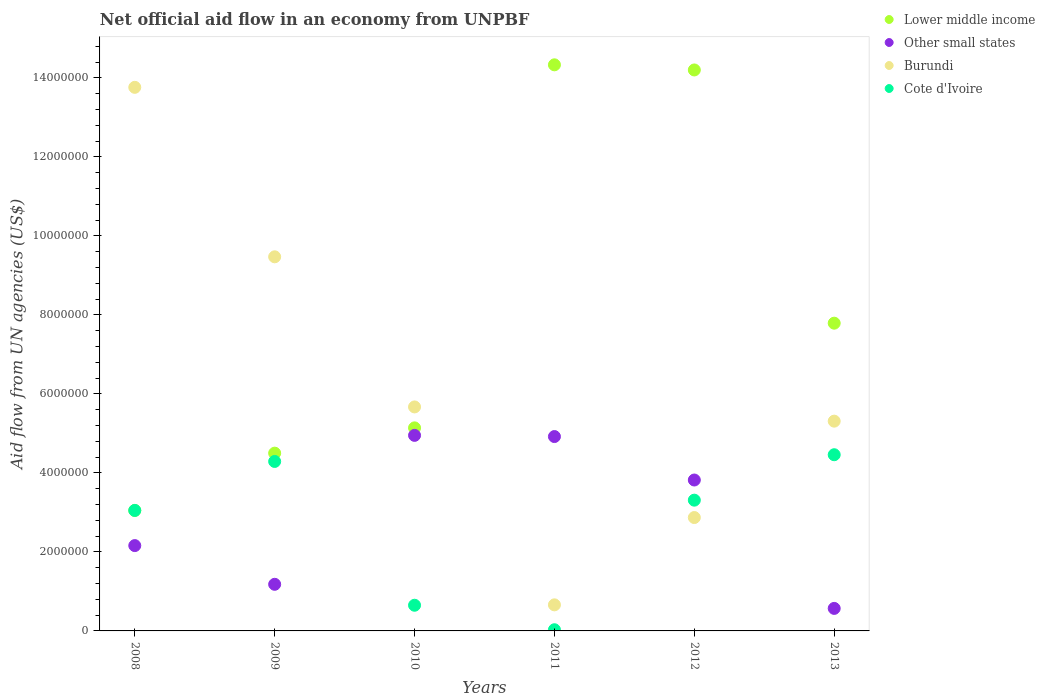What is the net official aid flow in Lower middle income in 2008?
Offer a terse response. 3.05e+06. Across all years, what is the maximum net official aid flow in Burundi?
Your answer should be very brief. 1.38e+07. Across all years, what is the minimum net official aid flow in Other small states?
Give a very brief answer. 5.70e+05. In which year was the net official aid flow in Cote d'Ivoire maximum?
Give a very brief answer. 2013. In which year was the net official aid flow in Cote d'Ivoire minimum?
Offer a terse response. 2011. What is the total net official aid flow in Lower middle income in the graph?
Provide a short and direct response. 4.90e+07. What is the difference between the net official aid flow in Burundi in 2009 and that in 2011?
Your answer should be compact. 8.81e+06. What is the difference between the net official aid flow in Cote d'Ivoire in 2008 and the net official aid flow in Burundi in 2012?
Give a very brief answer. 1.80e+05. What is the average net official aid flow in Other small states per year?
Ensure brevity in your answer.  2.93e+06. In the year 2010, what is the difference between the net official aid flow in Lower middle income and net official aid flow in Cote d'Ivoire?
Make the answer very short. 4.49e+06. What is the ratio of the net official aid flow in Burundi in 2009 to that in 2011?
Your response must be concise. 14.35. Is the net official aid flow in Cote d'Ivoire in 2009 less than that in 2012?
Make the answer very short. No. What is the difference between the highest and the second highest net official aid flow in Other small states?
Provide a short and direct response. 3.00e+04. What is the difference between the highest and the lowest net official aid flow in Burundi?
Make the answer very short. 1.31e+07. In how many years, is the net official aid flow in Other small states greater than the average net official aid flow in Other small states taken over all years?
Keep it short and to the point. 3. Is the sum of the net official aid flow in Burundi in 2008 and 2012 greater than the maximum net official aid flow in Other small states across all years?
Offer a terse response. Yes. Does the net official aid flow in Other small states monotonically increase over the years?
Your answer should be compact. No. How many dotlines are there?
Your answer should be very brief. 4. How many years are there in the graph?
Provide a succinct answer. 6. Does the graph contain any zero values?
Keep it short and to the point. No. Does the graph contain grids?
Your answer should be very brief. No. Where does the legend appear in the graph?
Keep it short and to the point. Top right. How are the legend labels stacked?
Your answer should be very brief. Vertical. What is the title of the graph?
Offer a very short reply. Net official aid flow in an economy from UNPBF. Does "Comoros" appear as one of the legend labels in the graph?
Provide a short and direct response. No. What is the label or title of the X-axis?
Keep it short and to the point. Years. What is the label or title of the Y-axis?
Your response must be concise. Aid flow from UN agencies (US$). What is the Aid flow from UN agencies (US$) in Lower middle income in 2008?
Provide a succinct answer. 3.05e+06. What is the Aid flow from UN agencies (US$) of Other small states in 2008?
Your response must be concise. 2.16e+06. What is the Aid flow from UN agencies (US$) in Burundi in 2008?
Provide a short and direct response. 1.38e+07. What is the Aid flow from UN agencies (US$) in Cote d'Ivoire in 2008?
Provide a short and direct response. 3.05e+06. What is the Aid flow from UN agencies (US$) in Lower middle income in 2009?
Your answer should be very brief. 4.50e+06. What is the Aid flow from UN agencies (US$) in Other small states in 2009?
Your answer should be very brief. 1.18e+06. What is the Aid flow from UN agencies (US$) of Burundi in 2009?
Your answer should be very brief. 9.47e+06. What is the Aid flow from UN agencies (US$) in Cote d'Ivoire in 2009?
Provide a succinct answer. 4.29e+06. What is the Aid flow from UN agencies (US$) in Lower middle income in 2010?
Keep it short and to the point. 5.14e+06. What is the Aid flow from UN agencies (US$) in Other small states in 2010?
Your response must be concise. 4.95e+06. What is the Aid flow from UN agencies (US$) of Burundi in 2010?
Offer a very short reply. 5.67e+06. What is the Aid flow from UN agencies (US$) in Cote d'Ivoire in 2010?
Provide a short and direct response. 6.50e+05. What is the Aid flow from UN agencies (US$) in Lower middle income in 2011?
Your response must be concise. 1.43e+07. What is the Aid flow from UN agencies (US$) of Other small states in 2011?
Your answer should be compact. 4.92e+06. What is the Aid flow from UN agencies (US$) of Cote d'Ivoire in 2011?
Provide a succinct answer. 3.00e+04. What is the Aid flow from UN agencies (US$) in Lower middle income in 2012?
Offer a very short reply. 1.42e+07. What is the Aid flow from UN agencies (US$) of Other small states in 2012?
Your response must be concise. 3.82e+06. What is the Aid flow from UN agencies (US$) of Burundi in 2012?
Your response must be concise. 2.87e+06. What is the Aid flow from UN agencies (US$) of Cote d'Ivoire in 2012?
Offer a terse response. 3.31e+06. What is the Aid flow from UN agencies (US$) in Lower middle income in 2013?
Offer a very short reply. 7.79e+06. What is the Aid flow from UN agencies (US$) in Other small states in 2013?
Provide a short and direct response. 5.70e+05. What is the Aid flow from UN agencies (US$) in Burundi in 2013?
Offer a terse response. 5.31e+06. What is the Aid flow from UN agencies (US$) in Cote d'Ivoire in 2013?
Your response must be concise. 4.46e+06. Across all years, what is the maximum Aid flow from UN agencies (US$) of Lower middle income?
Your answer should be compact. 1.43e+07. Across all years, what is the maximum Aid flow from UN agencies (US$) in Other small states?
Offer a terse response. 4.95e+06. Across all years, what is the maximum Aid flow from UN agencies (US$) in Burundi?
Offer a terse response. 1.38e+07. Across all years, what is the maximum Aid flow from UN agencies (US$) of Cote d'Ivoire?
Give a very brief answer. 4.46e+06. Across all years, what is the minimum Aid flow from UN agencies (US$) in Lower middle income?
Offer a terse response. 3.05e+06. Across all years, what is the minimum Aid flow from UN agencies (US$) of Other small states?
Give a very brief answer. 5.70e+05. Across all years, what is the minimum Aid flow from UN agencies (US$) of Cote d'Ivoire?
Offer a terse response. 3.00e+04. What is the total Aid flow from UN agencies (US$) in Lower middle income in the graph?
Provide a succinct answer. 4.90e+07. What is the total Aid flow from UN agencies (US$) in Other small states in the graph?
Offer a terse response. 1.76e+07. What is the total Aid flow from UN agencies (US$) in Burundi in the graph?
Provide a succinct answer. 3.77e+07. What is the total Aid flow from UN agencies (US$) of Cote d'Ivoire in the graph?
Ensure brevity in your answer.  1.58e+07. What is the difference between the Aid flow from UN agencies (US$) in Lower middle income in 2008 and that in 2009?
Offer a terse response. -1.45e+06. What is the difference between the Aid flow from UN agencies (US$) in Other small states in 2008 and that in 2009?
Give a very brief answer. 9.80e+05. What is the difference between the Aid flow from UN agencies (US$) of Burundi in 2008 and that in 2009?
Provide a succinct answer. 4.29e+06. What is the difference between the Aid flow from UN agencies (US$) in Cote d'Ivoire in 2008 and that in 2009?
Give a very brief answer. -1.24e+06. What is the difference between the Aid flow from UN agencies (US$) of Lower middle income in 2008 and that in 2010?
Make the answer very short. -2.09e+06. What is the difference between the Aid flow from UN agencies (US$) in Other small states in 2008 and that in 2010?
Ensure brevity in your answer.  -2.79e+06. What is the difference between the Aid flow from UN agencies (US$) of Burundi in 2008 and that in 2010?
Provide a succinct answer. 8.09e+06. What is the difference between the Aid flow from UN agencies (US$) in Cote d'Ivoire in 2008 and that in 2010?
Offer a terse response. 2.40e+06. What is the difference between the Aid flow from UN agencies (US$) in Lower middle income in 2008 and that in 2011?
Your answer should be very brief. -1.13e+07. What is the difference between the Aid flow from UN agencies (US$) of Other small states in 2008 and that in 2011?
Keep it short and to the point. -2.76e+06. What is the difference between the Aid flow from UN agencies (US$) in Burundi in 2008 and that in 2011?
Your answer should be compact. 1.31e+07. What is the difference between the Aid flow from UN agencies (US$) in Cote d'Ivoire in 2008 and that in 2011?
Keep it short and to the point. 3.02e+06. What is the difference between the Aid flow from UN agencies (US$) in Lower middle income in 2008 and that in 2012?
Your response must be concise. -1.12e+07. What is the difference between the Aid flow from UN agencies (US$) of Other small states in 2008 and that in 2012?
Give a very brief answer. -1.66e+06. What is the difference between the Aid flow from UN agencies (US$) of Burundi in 2008 and that in 2012?
Ensure brevity in your answer.  1.09e+07. What is the difference between the Aid flow from UN agencies (US$) of Cote d'Ivoire in 2008 and that in 2012?
Keep it short and to the point. -2.60e+05. What is the difference between the Aid flow from UN agencies (US$) in Lower middle income in 2008 and that in 2013?
Keep it short and to the point. -4.74e+06. What is the difference between the Aid flow from UN agencies (US$) in Other small states in 2008 and that in 2013?
Your response must be concise. 1.59e+06. What is the difference between the Aid flow from UN agencies (US$) in Burundi in 2008 and that in 2013?
Keep it short and to the point. 8.45e+06. What is the difference between the Aid flow from UN agencies (US$) of Cote d'Ivoire in 2008 and that in 2013?
Offer a terse response. -1.41e+06. What is the difference between the Aid flow from UN agencies (US$) in Lower middle income in 2009 and that in 2010?
Your answer should be very brief. -6.40e+05. What is the difference between the Aid flow from UN agencies (US$) of Other small states in 2009 and that in 2010?
Your response must be concise. -3.77e+06. What is the difference between the Aid flow from UN agencies (US$) in Burundi in 2009 and that in 2010?
Provide a succinct answer. 3.80e+06. What is the difference between the Aid flow from UN agencies (US$) in Cote d'Ivoire in 2009 and that in 2010?
Ensure brevity in your answer.  3.64e+06. What is the difference between the Aid flow from UN agencies (US$) of Lower middle income in 2009 and that in 2011?
Keep it short and to the point. -9.83e+06. What is the difference between the Aid flow from UN agencies (US$) in Other small states in 2009 and that in 2011?
Provide a succinct answer. -3.74e+06. What is the difference between the Aid flow from UN agencies (US$) in Burundi in 2009 and that in 2011?
Provide a short and direct response. 8.81e+06. What is the difference between the Aid flow from UN agencies (US$) of Cote d'Ivoire in 2009 and that in 2011?
Your answer should be very brief. 4.26e+06. What is the difference between the Aid flow from UN agencies (US$) of Lower middle income in 2009 and that in 2012?
Offer a very short reply. -9.70e+06. What is the difference between the Aid flow from UN agencies (US$) in Other small states in 2009 and that in 2012?
Your answer should be very brief. -2.64e+06. What is the difference between the Aid flow from UN agencies (US$) in Burundi in 2009 and that in 2012?
Ensure brevity in your answer.  6.60e+06. What is the difference between the Aid flow from UN agencies (US$) of Cote d'Ivoire in 2009 and that in 2012?
Offer a terse response. 9.80e+05. What is the difference between the Aid flow from UN agencies (US$) of Lower middle income in 2009 and that in 2013?
Give a very brief answer. -3.29e+06. What is the difference between the Aid flow from UN agencies (US$) of Other small states in 2009 and that in 2013?
Ensure brevity in your answer.  6.10e+05. What is the difference between the Aid flow from UN agencies (US$) of Burundi in 2009 and that in 2013?
Offer a very short reply. 4.16e+06. What is the difference between the Aid flow from UN agencies (US$) of Cote d'Ivoire in 2009 and that in 2013?
Make the answer very short. -1.70e+05. What is the difference between the Aid flow from UN agencies (US$) of Lower middle income in 2010 and that in 2011?
Make the answer very short. -9.19e+06. What is the difference between the Aid flow from UN agencies (US$) of Burundi in 2010 and that in 2011?
Your response must be concise. 5.01e+06. What is the difference between the Aid flow from UN agencies (US$) in Cote d'Ivoire in 2010 and that in 2011?
Provide a succinct answer. 6.20e+05. What is the difference between the Aid flow from UN agencies (US$) in Lower middle income in 2010 and that in 2012?
Offer a terse response. -9.06e+06. What is the difference between the Aid flow from UN agencies (US$) of Other small states in 2010 and that in 2012?
Your answer should be compact. 1.13e+06. What is the difference between the Aid flow from UN agencies (US$) in Burundi in 2010 and that in 2012?
Your answer should be very brief. 2.80e+06. What is the difference between the Aid flow from UN agencies (US$) in Cote d'Ivoire in 2010 and that in 2012?
Offer a terse response. -2.66e+06. What is the difference between the Aid flow from UN agencies (US$) in Lower middle income in 2010 and that in 2013?
Ensure brevity in your answer.  -2.65e+06. What is the difference between the Aid flow from UN agencies (US$) of Other small states in 2010 and that in 2013?
Your response must be concise. 4.38e+06. What is the difference between the Aid flow from UN agencies (US$) of Cote d'Ivoire in 2010 and that in 2013?
Keep it short and to the point. -3.81e+06. What is the difference between the Aid flow from UN agencies (US$) in Lower middle income in 2011 and that in 2012?
Offer a terse response. 1.30e+05. What is the difference between the Aid flow from UN agencies (US$) of Other small states in 2011 and that in 2012?
Offer a very short reply. 1.10e+06. What is the difference between the Aid flow from UN agencies (US$) of Burundi in 2011 and that in 2012?
Your answer should be compact. -2.21e+06. What is the difference between the Aid flow from UN agencies (US$) of Cote d'Ivoire in 2011 and that in 2012?
Your answer should be compact. -3.28e+06. What is the difference between the Aid flow from UN agencies (US$) of Lower middle income in 2011 and that in 2013?
Make the answer very short. 6.54e+06. What is the difference between the Aid flow from UN agencies (US$) of Other small states in 2011 and that in 2013?
Your response must be concise. 4.35e+06. What is the difference between the Aid flow from UN agencies (US$) of Burundi in 2011 and that in 2013?
Offer a very short reply. -4.65e+06. What is the difference between the Aid flow from UN agencies (US$) in Cote d'Ivoire in 2011 and that in 2013?
Offer a terse response. -4.43e+06. What is the difference between the Aid flow from UN agencies (US$) of Lower middle income in 2012 and that in 2013?
Keep it short and to the point. 6.41e+06. What is the difference between the Aid flow from UN agencies (US$) of Other small states in 2012 and that in 2013?
Offer a terse response. 3.25e+06. What is the difference between the Aid flow from UN agencies (US$) of Burundi in 2012 and that in 2013?
Give a very brief answer. -2.44e+06. What is the difference between the Aid flow from UN agencies (US$) of Cote d'Ivoire in 2012 and that in 2013?
Offer a terse response. -1.15e+06. What is the difference between the Aid flow from UN agencies (US$) of Lower middle income in 2008 and the Aid flow from UN agencies (US$) of Other small states in 2009?
Provide a short and direct response. 1.87e+06. What is the difference between the Aid flow from UN agencies (US$) of Lower middle income in 2008 and the Aid flow from UN agencies (US$) of Burundi in 2009?
Your answer should be compact. -6.42e+06. What is the difference between the Aid flow from UN agencies (US$) of Lower middle income in 2008 and the Aid flow from UN agencies (US$) of Cote d'Ivoire in 2009?
Offer a very short reply. -1.24e+06. What is the difference between the Aid flow from UN agencies (US$) in Other small states in 2008 and the Aid flow from UN agencies (US$) in Burundi in 2009?
Offer a very short reply. -7.31e+06. What is the difference between the Aid flow from UN agencies (US$) of Other small states in 2008 and the Aid flow from UN agencies (US$) of Cote d'Ivoire in 2009?
Ensure brevity in your answer.  -2.13e+06. What is the difference between the Aid flow from UN agencies (US$) in Burundi in 2008 and the Aid flow from UN agencies (US$) in Cote d'Ivoire in 2009?
Make the answer very short. 9.47e+06. What is the difference between the Aid flow from UN agencies (US$) of Lower middle income in 2008 and the Aid flow from UN agencies (US$) of Other small states in 2010?
Your response must be concise. -1.90e+06. What is the difference between the Aid flow from UN agencies (US$) in Lower middle income in 2008 and the Aid flow from UN agencies (US$) in Burundi in 2010?
Keep it short and to the point. -2.62e+06. What is the difference between the Aid flow from UN agencies (US$) of Lower middle income in 2008 and the Aid flow from UN agencies (US$) of Cote d'Ivoire in 2010?
Provide a short and direct response. 2.40e+06. What is the difference between the Aid flow from UN agencies (US$) of Other small states in 2008 and the Aid flow from UN agencies (US$) of Burundi in 2010?
Your answer should be very brief. -3.51e+06. What is the difference between the Aid flow from UN agencies (US$) in Other small states in 2008 and the Aid flow from UN agencies (US$) in Cote d'Ivoire in 2010?
Ensure brevity in your answer.  1.51e+06. What is the difference between the Aid flow from UN agencies (US$) in Burundi in 2008 and the Aid flow from UN agencies (US$) in Cote d'Ivoire in 2010?
Provide a short and direct response. 1.31e+07. What is the difference between the Aid flow from UN agencies (US$) of Lower middle income in 2008 and the Aid flow from UN agencies (US$) of Other small states in 2011?
Provide a succinct answer. -1.87e+06. What is the difference between the Aid flow from UN agencies (US$) in Lower middle income in 2008 and the Aid flow from UN agencies (US$) in Burundi in 2011?
Your answer should be very brief. 2.39e+06. What is the difference between the Aid flow from UN agencies (US$) of Lower middle income in 2008 and the Aid flow from UN agencies (US$) of Cote d'Ivoire in 2011?
Give a very brief answer. 3.02e+06. What is the difference between the Aid flow from UN agencies (US$) of Other small states in 2008 and the Aid flow from UN agencies (US$) of Burundi in 2011?
Offer a very short reply. 1.50e+06. What is the difference between the Aid flow from UN agencies (US$) of Other small states in 2008 and the Aid flow from UN agencies (US$) of Cote d'Ivoire in 2011?
Offer a very short reply. 2.13e+06. What is the difference between the Aid flow from UN agencies (US$) of Burundi in 2008 and the Aid flow from UN agencies (US$) of Cote d'Ivoire in 2011?
Your answer should be very brief. 1.37e+07. What is the difference between the Aid flow from UN agencies (US$) in Lower middle income in 2008 and the Aid flow from UN agencies (US$) in Other small states in 2012?
Your answer should be compact. -7.70e+05. What is the difference between the Aid flow from UN agencies (US$) in Lower middle income in 2008 and the Aid flow from UN agencies (US$) in Burundi in 2012?
Offer a very short reply. 1.80e+05. What is the difference between the Aid flow from UN agencies (US$) in Lower middle income in 2008 and the Aid flow from UN agencies (US$) in Cote d'Ivoire in 2012?
Provide a short and direct response. -2.60e+05. What is the difference between the Aid flow from UN agencies (US$) in Other small states in 2008 and the Aid flow from UN agencies (US$) in Burundi in 2012?
Provide a succinct answer. -7.10e+05. What is the difference between the Aid flow from UN agencies (US$) in Other small states in 2008 and the Aid flow from UN agencies (US$) in Cote d'Ivoire in 2012?
Your answer should be compact. -1.15e+06. What is the difference between the Aid flow from UN agencies (US$) of Burundi in 2008 and the Aid flow from UN agencies (US$) of Cote d'Ivoire in 2012?
Your response must be concise. 1.04e+07. What is the difference between the Aid flow from UN agencies (US$) of Lower middle income in 2008 and the Aid flow from UN agencies (US$) of Other small states in 2013?
Keep it short and to the point. 2.48e+06. What is the difference between the Aid flow from UN agencies (US$) of Lower middle income in 2008 and the Aid flow from UN agencies (US$) of Burundi in 2013?
Provide a succinct answer. -2.26e+06. What is the difference between the Aid flow from UN agencies (US$) of Lower middle income in 2008 and the Aid flow from UN agencies (US$) of Cote d'Ivoire in 2013?
Ensure brevity in your answer.  -1.41e+06. What is the difference between the Aid flow from UN agencies (US$) in Other small states in 2008 and the Aid flow from UN agencies (US$) in Burundi in 2013?
Your answer should be very brief. -3.15e+06. What is the difference between the Aid flow from UN agencies (US$) of Other small states in 2008 and the Aid flow from UN agencies (US$) of Cote d'Ivoire in 2013?
Give a very brief answer. -2.30e+06. What is the difference between the Aid flow from UN agencies (US$) of Burundi in 2008 and the Aid flow from UN agencies (US$) of Cote d'Ivoire in 2013?
Give a very brief answer. 9.30e+06. What is the difference between the Aid flow from UN agencies (US$) in Lower middle income in 2009 and the Aid flow from UN agencies (US$) in Other small states in 2010?
Ensure brevity in your answer.  -4.50e+05. What is the difference between the Aid flow from UN agencies (US$) in Lower middle income in 2009 and the Aid flow from UN agencies (US$) in Burundi in 2010?
Your answer should be compact. -1.17e+06. What is the difference between the Aid flow from UN agencies (US$) of Lower middle income in 2009 and the Aid flow from UN agencies (US$) of Cote d'Ivoire in 2010?
Make the answer very short. 3.85e+06. What is the difference between the Aid flow from UN agencies (US$) in Other small states in 2009 and the Aid flow from UN agencies (US$) in Burundi in 2010?
Give a very brief answer. -4.49e+06. What is the difference between the Aid flow from UN agencies (US$) of Other small states in 2009 and the Aid flow from UN agencies (US$) of Cote d'Ivoire in 2010?
Your answer should be compact. 5.30e+05. What is the difference between the Aid flow from UN agencies (US$) of Burundi in 2009 and the Aid flow from UN agencies (US$) of Cote d'Ivoire in 2010?
Offer a terse response. 8.82e+06. What is the difference between the Aid flow from UN agencies (US$) of Lower middle income in 2009 and the Aid flow from UN agencies (US$) of Other small states in 2011?
Keep it short and to the point. -4.20e+05. What is the difference between the Aid flow from UN agencies (US$) in Lower middle income in 2009 and the Aid flow from UN agencies (US$) in Burundi in 2011?
Offer a very short reply. 3.84e+06. What is the difference between the Aid flow from UN agencies (US$) in Lower middle income in 2009 and the Aid flow from UN agencies (US$) in Cote d'Ivoire in 2011?
Provide a short and direct response. 4.47e+06. What is the difference between the Aid flow from UN agencies (US$) of Other small states in 2009 and the Aid flow from UN agencies (US$) of Burundi in 2011?
Provide a succinct answer. 5.20e+05. What is the difference between the Aid flow from UN agencies (US$) in Other small states in 2009 and the Aid flow from UN agencies (US$) in Cote d'Ivoire in 2011?
Give a very brief answer. 1.15e+06. What is the difference between the Aid flow from UN agencies (US$) in Burundi in 2009 and the Aid flow from UN agencies (US$) in Cote d'Ivoire in 2011?
Ensure brevity in your answer.  9.44e+06. What is the difference between the Aid flow from UN agencies (US$) of Lower middle income in 2009 and the Aid flow from UN agencies (US$) of Other small states in 2012?
Provide a succinct answer. 6.80e+05. What is the difference between the Aid flow from UN agencies (US$) of Lower middle income in 2009 and the Aid flow from UN agencies (US$) of Burundi in 2012?
Give a very brief answer. 1.63e+06. What is the difference between the Aid flow from UN agencies (US$) of Lower middle income in 2009 and the Aid flow from UN agencies (US$) of Cote d'Ivoire in 2012?
Provide a short and direct response. 1.19e+06. What is the difference between the Aid flow from UN agencies (US$) in Other small states in 2009 and the Aid flow from UN agencies (US$) in Burundi in 2012?
Keep it short and to the point. -1.69e+06. What is the difference between the Aid flow from UN agencies (US$) of Other small states in 2009 and the Aid flow from UN agencies (US$) of Cote d'Ivoire in 2012?
Your answer should be very brief. -2.13e+06. What is the difference between the Aid flow from UN agencies (US$) in Burundi in 2009 and the Aid flow from UN agencies (US$) in Cote d'Ivoire in 2012?
Your response must be concise. 6.16e+06. What is the difference between the Aid flow from UN agencies (US$) in Lower middle income in 2009 and the Aid flow from UN agencies (US$) in Other small states in 2013?
Your answer should be very brief. 3.93e+06. What is the difference between the Aid flow from UN agencies (US$) of Lower middle income in 2009 and the Aid flow from UN agencies (US$) of Burundi in 2013?
Offer a terse response. -8.10e+05. What is the difference between the Aid flow from UN agencies (US$) in Lower middle income in 2009 and the Aid flow from UN agencies (US$) in Cote d'Ivoire in 2013?
Give a very brief answer. 4.00e+04. What is the difference between the Aid flow from UN agencies (US$) in Other small states in 2009 and the Aid flow from UN agencies (US$) in Burundi in 2013?
Give a very brief answer. -4.13e+06. What is the difference between the Aid flow from UN agencies (US$) of Other small states in 2009 and the Aid flow from UN agencies (US$) of Cote d'Ivoire in 2013?
Give a very brief answer. -3.28e+06. What is the difference between the Aid flow from UN agencies (US$) of Burundi in 2009 and the Aid flow from UN agencies (US$) of Cote d'Ivoire in 2013?
Give a very brief answer. 5.01e+06. What is the difference between the Aid flow from UN agencies (US$) of Lower middle income in 2010 and the Aid flow from UN agencies (US$) of Other small states in 2011?
Offer a very short reply. 2.20e+05. What is the difference between the Aid flow from UN agencies (US$) of Lower middle income in 2010 and the Aid flow from UN agencies (US$) of Burundi in 2011?
Your response must be concise. 4.48e+06. What is the difference between the Aid flow from UN agencies (US$) of Lower middle income in 2010 and the Aid flow from UN agencies (US$) of Cote d'Ivoire in 2011?
Ensure brevity in your answer.  5.11e+06. What is the difference between the Aid flow from UN agencies (US$) in Other small states in 2010 and the Aid flow from UN agencies (US$) in Burundi in 2011?
Provide a succinct answer. 4.29e+06. What is the difference between the Aid flow from UN agencies (US$) in Other small states in 2010 and the Aid flow from UN agencies (US$) in Cote d'Ivoire in 2011?
Give a very brief answer. 4.92e+06. What is the difference between the Aid flow from UN agencies (US$) of Burundi in 2010 and the Aid flow from UN agencies (US$) of Cote d'Ivoire in 2011?
Provide a short and direct response. 5.64e+06. What is the difference between the Aid flow from UN agencies (US$) in Lower middle income in 2010 and the Aid flow from UN agencies (US$) in Other small states in 2012?
Give a very brief answer. 1.32e+06. What is the difference between the Aid flow from UN agencies (US$) of Lower middle income in 2010 and the Aid flow from UN agencies (US$) of Burundi in 2012?
Your response must be concise. 2.27e+06. What is the difference between the Aid flow from UN agencies (US$) of Lower middle income in 2010 and the Aid flow from UN agencies (US$) of Cote d'Ivoire in 2012?
Your answer should be very brief. 1.83e+06. What is the difference between the Aid flow from UN agencies (US$) of Other small states in 2010 and the Aid flow from UN agencies (US$) of Burundi in 2012?
Provide a succinct answer. 2.08e+06. What is the difference between the Aid flow from UN agencies (US$) in Other small states in 2010 and the Aid flow from UN agencies (US$) in Cote d'Ivoire in 2012?
Ensure brevity in your answer.  1.64e+06. What is the difference between the Aid flow from UN agencies (US$) in Burundi in 2010 and the Aid flow from UN agencies (US$) in Cote d'Ivoire in 2012?
Make the answer very short. 2.36e+06. What is the difference between the Aid flow from UN agencies (US$) of Lower middle income in 2010 and the Aid flow from UN agencies (US$) of Other small states in 2013?
Give a very brief answer. 4.57e+06. What is the difference between the Aid flow from UN agencies (US$) of Lower middle income in 2010 and the Aid flow from UN agencies (US$) of Burundi in 2013?
Provide a succinct answer. -1.70e+05. What is the difference between the Aid flow from UN agencies (US$) in Lower middle income in 2010 and the Aid flow from UN agencies (US$) in Cote d'Ivoire in 2013?
Keep it short and to the point. 6.80e+05. What is the difference between the Aid flow from UN agencies (US$) of Other small states in 2010 and the Aid flow from UN agencies (US$) of Burundi in 2013?
Your answer should be compact. -3.60e+05. What is the difference between the Aid flow from UN agencies (US$) in Burundi in 2010 and the Aid flow from UN agencies (US$) in Cote d'Ivoire in 2013?
Offer a very short reply. 1.21e+06. What is the difference between the Aid flow from UN agencies (US$) in Lower middle income in 2011 and the Aid flow from UN agencies (US$) in Other small states in 2012?
Give a very brief answer. 1.05e+07. What is the difference between the Aid flow from UN agencies (US$) of Lower middle income in 2011 and the Aid flow from UN agencies (US$) of Burundi in 2012?
Keep it short and to the point. 1.15e+07. What is the difference between the Aid flow from UN agencies (US$) of Lower middle income in 2011 and the Aid flow from UN agencies (US$) of Cote d'Ivoire in 2012?
Provide a succinct answer. 1.10e+07. What is the difference between the Aid flow from UN agencies (US$) in Other small states in 2011 and the Aid flow from UN agencies (US$) in Burundi in 2012?
Provide a succinct answer. 2.05e+06. What is the difference between the Aid flow from UN agencies (US$) of Other small states in 2011 and the Aid flow from UN agencies (US$) of Cote d'Ivoire in 2012?
Offer a terse response. 1.61e+06. What is the difference between the Aid flow from UN agencies (US$) of Burundi in 2011 and the Aid flow from UN agencies (US$) of Cote d'Ivoire in 2012?
Make the answer very short. -2.65e+06. What is the difference between the Aid flow from UN agencies (US$) of Lower middle income in 2011 and the Aid flow from UN agencies (US$) of Other small states in 2013?
Your response must be concise. 1.38e+07. What is the difference between the Aid flow from UN agencies (US$) of Lower middle income in 2011 and the Aid flow from UN agencies (US$) of Burundi in 2013?
Make the answer very short. 9.02e+06. What is the difference between the Aid flow from UN agencies (US$) of Lower middle income in 2011 and the Aid flow from UN agencies (US$) of Cote d'Ivoire in 2013?
Provide a short and direct response. 9.87e+06. What is the difference between the Aid flow from UN agencies (US$) of Other small states in 2011 and the Aid flow from UN agencies (US$) of Burundi in 2013?
Offer a terse response. -3.90e+05. What is the difference between the Aid flow from UN agencies (US$) of Other small states in 2011 and the Aid flow from UN agencies (US$) of Cote d'Ivoire in 2013?
Provide a succinct answer. 4.60e+05. What is the difference between the Aid flow from UN agencies (US$) of Burundi in 2011 and the Aid flow from UN agencies (US$) of Cote d'Ivoire in 2013?
Offer a very short reply. -3.80e+06. What is the difference between the Aid flow from UN agencies (US$) of Lower middle income in 2012 and the Aid flow from UN agencies (US$) of Other small states in 2013?
Your answer should be compact. 1.36e+07. What is the difference between the Aid flow from UN agencies (US$) of Lower middle income in 2012 and the Aid flow from UN agencies (US$) of Burundi in 2013?
Give a very brief answer. 8.89e+06. What is the difference between the Aid flow from UN agencies (US$) in Lower middle income in 2012 and the Aid flow from UN agencies (US$) in Cote d'Ivoire in 2013?
Your answer should be very brief. 9.74e+06. What is the difference between the Aid flow from UN agencies (US$) of Other small states in 2012 and the Aid flow from UN agencies (US$) of Burundi in 2013?
Offer a terse response. -1.49e+06. What is the difference between the Aid flow from UN agencies (US$) in Other small states in 2012 and the Aid flow from UN agencies (US$) in Cote d'Ivoire in 2013?
Your answer should be compact. -6.40e+05. What is the difference between the Aid flow from UN agencies (US$) of Burundi in 2012 and the Aid flow from UN agencies (US$) of Cote d'Ivoire in 2013?
Provide a succinct answer. -1.59e+06. What is the average Aid flow from UN agencies (US$) in Lower middle income per year?
Your answer should be very brief. 8.17e+06. What is the average Aid flow from UN agencies (US$) of Other small states per year?
Provide a succinct answer. 2.93e+06. What is the average Aid flow from UN agencies (US$) in Burundi per year?
Make the answer very short. 6.29e+06. What is the average Aid flow from UN agencies (US$) of Cote d'Ivoire per year?
Provide a succinct answer. 2.63e+06. In the year 2008, what is the difference between the Aid flow from UN agencies (US$) in Lower middle income and Aid flow from UN agencies (US$) in Other small states?
Keep it short and to the point. 8.90e+05. In the year 2008, what is the difference between the Aid flow from UN agencies (US$) of Lower middle income and Aid flow from UN agencies (US$) of Burundi?
Your response must be concise. -1.07e+07. In the year 2008, what is the difference between the Aid flow from UN agencies (US$) of Lower middle income and Aid flow from UN agencies (US$) of Cote d'Ivoire?
Your answer should be very brief. 0. In the year 2008, what is the difference between the Aid flow from UN agencies (US$) in Other small states and Aid flow from UN agencies (US$) in Burundi?
Your answer should be compact. -1.16e+07. In the year 2008, what is the difference between the Aid flow from UN agencies (US$) in Other small states and Aid flow from UN agencies (US$) in Cote d'Ivoire?
Provide a succinct answer. -8.90e+05. In the year 2008, what is the difference between the Aid flow from UN agencies (US$) in Burundi and Aid flow from UN agencies (US$) in Cote d'Ivoire?
Give a very brief answer. 1.07e+07. In the year 2009, what is the difference between the Aid flow from UN agencies (US$) in Lower middle income and Aid flow from UN agencies (US$) in Other small states?
Your response must be concise. 3.32e+06. In the year 2009, what is the difference between the Aid flow from UN agencies (US$) in Lower middle income and Aid flow from UN agencies (US$) in Burundi?
Make the answer very short. -4.97e+06. In the year 2009, what is the difference between the Aid flow from UN agencies (US$) in Other small states and Aid flow from UN agencies (US$) in Burundi?
Offer a very short reply. -8.29e+06. In the year 2009, what is the difference between the Aid flow from UN agencies (US$) of Other small states and Aid flow from UN agencies (US$) of Cote d'Ivoire?
Ensure brevity in your answer.  -3.11e+06. In the year 2009, what is the difference between the Aid flow from UN agencies (US$) of Burundi and Aid flow from UN agencies (US$) of Cote d'Ivoire?
Make the answer very short. 5.18e+06. In the year 2010, what is the difference between the Aid flow from UN agencies (US$) of Lower middle income and Aid flow from UN agencies (US$) of Other small states?
Your answer should be very brief. 1.90e+05. In the year 2010, what is the difference between the Aid flow from UN agencies (US$) of Lower middle income and Aid flow from UN agencies (US$) of Burundi?
Provide a succinct answer. -5.30e+05. In the year 2010, what is the difference between the Aid flow from UN agencies (US$) of Lower middle income and Aid flow from UN agencies (US$) of Cote d'Ivoire?
Offer a very short reply. 4.49e+06. In the year 2010, what is the difference between the Aid flow from UN agencies (US$) in Other small states and Aid flow from UN agencies (US$) in Burundi?
Offer a very short reply. -7.20e+05. In the year 2010, what is the difference between the Aid flow from UN agencies (US$) in Other small states and Aid flow from UN agencies (US$) in Cote d'Ivoire?
Ensure brevity in your answer.  4.30e+06. In the year 2010, what is the difference between the Aid flow from UN agencies (US$) in Burundi and Aid flow from UN agencies (US$) in Cote d'Ivoire?
Your answer should be compact. 5.02e+06. In the year 2011, what is the difference between the Aid flow from UN agencies (US$) in Lower middle income and Aid flow from UN agencies (US$) in Other small states?
Keep it short and to the point. 9.41e+06. In the year 2011, what is the difference between the Aid flow from UN agencies (US$) in Lower middle income and Aid flow from UN agencies (US$) in Burundi?
Your answer should be very brief. 1.37e+07. In the year 2011, what is the difference between the Aid flow from UN agencies (US$) in Lower middle income and Aid flow from UN agencies (US$) in Cote d'Ivoire?
Keep it short and to the point. 1.43e+07. In the year 2011, what is the difference between the Aid flow from UN agencies (US$) of Other small states and Aid flow from UN agencies (US$) of Burundi?
Your answer should be very brief. 4.26e+06. In the year 2011, what is the difference between the Aid flow from UN agencies (US$) of Other small states and Aid flow from UN agencies (US$) of Cote d'Ivoire?
Offer a terse response. 4.89e+06. In the year 2011, what is the difference between the Aid flow from UN agencies (US$) of Burundi and Aid flow from UN agencies (US$) of Cote d'Ivoire?
Ensure brevity in your answer.  6.30e+05. In the year 2012, what is the difference between the Aid flow from UN agencies (US$) of Lower middle income and Aid flow from UN agencies (US$) of Other small states?
Your answer should be compact. 1.04e+07. In the year 2012, what is the difference between the Aid flow from UN agencies (US$) in Lower middle income and Aid flow from UN agencies (US$) in Burundi?
Your answer should be very brief. 1.13e+07. In the year 2012, what is the difference between the Aid flow from UN agencies (US$) in Lower middle income and Aid flow from UN agencies (US$) in Cote d'Ivoire?
Provide a short and direct response. 1.09e+07. In the year 2012, what is the difference between the Aid flow from UN agencies (US$) of Other small states and Aid flow from UN agencies (US$) of Burundi?
Your answer should be compact. 9.50e+05. In the year 2012, what is the difference between the Aid flow from UN agencies (US$) in Other small states and Aid flow from UN agencies (US$) in Cote d'Ivoire?
Offer a terse response. 5.10e+05. In the year 2012, what is the difference between the Aid flow from UN agencies (US$) of Burundi and Aid flow from UN agencies (US$) of Cote d'Ivoire?
Your answer should be very brief. -4.40e+05. In the year 2013, what is the difference between the Aid flow from UN agencies (US$) of Lower middle income and Aid flow from UN agencies (US$) of Other small states?
Your response must be concise. 7.22e+06. In the year 2013, what is the difference between the Aid flow from UN agencies (US$) in Lower middle income and Aid flow from UN agencies (US$) in Burundi?
Keep it short and to the point. 2.48e+06. In the year 2013, what is the difference between the Aid flow from UN agencies (US$) in Lower middle income and Aid flow from UN agencies (US$) in Cote d'Ivoire?
Offer a very short reply. 3.33e+06. In the year 2013, what is the difference between the Aid flow from UN agencies (US$) of Other small states and Aid flow from UN agencies (US$) of Burundi?
Your response must be concise. -4.74e+06. In the year 2013, what is the difference between the Aid flow from UN agencies (US$) in Other small states and Aid flow from UN agencies (US$) in Cote d'Ivoire?
Give a very brief answer. -3.89e+06. In the year 2013, what is the difference between the Aid flow from UN agencies (US$) in Burundi and Aid flow from UN agencies (US$) in Cote d'Ivoire?
Your answer should be very brief. 8.50e+05. What is the ratio of the Aid flow from UN agencies (US$) of Lower middle income in 2008 to that in 2009?
Provide a short and direct response. 0.68. What is the ratio of the Aid flow from UN agencies (US$) in Other small states in 2008 to that in 2009?
Make the answer very short. 1.83. What is the ratio of the Aid flow from UN agencies (US$) in Burundi in 2008 to that in 2009?
Your response must be concise. 1.45. What is the ratio of the Aid flow from UN agencies (US$) in Cote d'Ivoire in 2008 to that in 2009?
Make the answer very short. 0.71. What is the ratio of the Aid flow from UN agencies (US$) of Lower middle income in 2008 to that in 2010?
Your answer should be very brief. 0.59. What is the ratio of the Aid flow from UN agencies (US$) of Other small states in 2008 to that in 2010?
Provide a short and direct response. 0.44. What is the ratio of the Aid flow from UN agencies (US$) of Burundi in 2008 to that in 2010?
Make the answer very short. 2.43. What is the ratio of the Aid flow from UN agencies (US$) in Cote d'Ivoire in 2008 to that in 2010?
Your response must be concise. 4.69. What is the ratio of the Aid flow from UN agencies (US$) of Lower middle income in 2008 to that in 2011?
Provide a short and direct response. 0.21. What is the ratio of the Aid flow from UN agencies (US$) in Other small states in 2008 to that in 2011?
Your answer should be compact. 0.44. What is the ratio of the Aid flow from UN agencies (US$) of Burundi in 2008 to that in 2011?
Provide a succinct answer. 20.85. What is the ratio of the Aid flow from UN agencies (US$) in Cote d'Ivoire in 2008 to that in 2011?
Keep it short and to the point. 101.67. What is the ratio of the Aid flow from UN agencies (US$) of Lower middle income in 2008 to that in 2012?
Offer a very short reply. 0.21. What is the ratio of the Aid flow from UN agencies (US$) in Other small states in 2008 to that in 2012?
Give a very brief answer. 0.57. What is the ratio of the Aid flow from UN agencies (US$) of Burundi in 2008 to that in 2012?
Your answer should be very brief. 4.79. What is the ratio of the Aid flow from UN agencies (US$) in Cote d'Ivoire in 2008 to that in 2012?
Ensure brevity in your answer.  0.92. What is the ratio of the Aid flow from UN agencies (US$) of Lower middle income in 2008 to that in 2013?
Your response must be concise. 0.39. What is the ratio of the Aid flow from UN agencies (US$) in Other small states in 2008 to that in 2013?
Your answer should be compact. 3.79. What is the ratio of the Aid flow from UN agencies (US$) of Burundi in 2008 to that in 2013?
Give a very brief answer. 2.59. What is the ratio of the Aid flow from UN agencies (US$) in Cote d'Ivoire in 2008 to that in 2013?
Provide a short and direct response. 0.68. What is the ratio of the Aid flow from UN agencies (US$) in Lower middle income in 2009 to that in 2010?
Offer a very short reply. 0.88. What is the ratio of the Aid flow from UN agencies (US$) of Other small states in 2009 to that in 2010?
Your answer should be very brief. 0.24. What is the ratio of the Aid flow from UN agencies (US$) in Burundi in 2009 to that in 2010?
Keep it short and to the point. 1.67. What is the ratio of the Aid flow from UN agencies (US$) of Lower middle income in 2009 to that in 2011?
Provide a short and direct response. 0.31. What is the ratio of the Aid flow from UN agencies (US$) in Other small states in 2009 to that in 2011?
Give a very brief answer. 0.24. What is the ratio of the Aid flow from UN agencies (US$) in Burundi in 2009 to that in 2011?
Provide a succinct answer. 14.35. What is the ratio of the Aid flow from UN agencies (US$) of Cote d'Ivoire in 2009 to that in 2011?
Offer a very short reply. 143. What is the ratio of the Aid flow from UN agencies (US$) in Lower middle income in 2009 to that in 2012?
Ensure brevity in your answer.  0.32. What is the ratio of the Aid flow from UN agencies (US$) of Other small states in 2009 to that in 2012?
Ensure brevity in your answer.  0.31. What is the ratio of the Aid flow from UN agencies (US$) of Burundi in 2009 to that in 2012?
Ensure brevity in your answer.  3.3. What is the ratio of the Aid flow from UN agencies (US$) of Cote d'Ivoire in 2009 to that in 2012?
Ensure brevity in your answer.  1.3. What is the ratio of the Aid flow from UN agencies (US$) in Lower middle income in 2009 to that in 2013?
Your answer should be very brief. 0.58. What is the ratio of the Aid flow from UN agencies (US$) in Other small states in 2009 to that in 2013?
Offer a terse response. 2.07. What is the ratio of the Aid flow from UN agencies (US$) of Burundi in 2009 to that in 2013?
Provide a short and direct response. 1.78. What is the ratio of the Aid flow from UN agencies (US$) of Cote d'Ivoire in 2009 to that in 2013?
Give a very brief answer. 0.96. What is the ratio of the Aid flow from UN agencies (US$) in Lower middle income in 2010 to that in 2011?
Keep it short and to the point. 0.36. What is the ratio of the Aid flow from UN agencies (US$) in Burundi in 2010 to that in 2011?
Offer a very short reply. 8.59. What is the ratio of the Aid flow from UN agencies (US$) in Cote d'Ivoire in 2010 to that in 2011?
Give a very brief answer. 21.67. What is the ratio of the Aid flow from UN agencies (US$) in Lower middle income in 2010 to that in 2012?
Your answer should be compact. 0.36. What is the ratio of the Aid flow from UN agencies (US$) of Other small states in 2010 to that in 2012?
Your answer should be compact. 1.3. What is the ratio of the Aid flow from UN agencies (US$) of Burundi in 2010 to that in 2012?
Ensure brevity in your answer.  1.98. What is the ratio of the Aid flow from UN agencies (US$) in Cote d'Ivoire in 2010 to that in 2012?
Provide a succinct answer. 0.2. What is the ratio of the Aid flow from UN agencies (US$) in Lower middle income in 2010 to that in 2013?
Ensure brevity in your answer.  0.66. What is the ratio of the Aid flow from UN agencies (US$) of Other small states in 2010 to that in 2013?
Offer a very short reply. 8.68. What is the ratio of the Aid flow from UN agencies (US$) of Burundi in 2010 to that in 2013?
Keep it short and to the point. 1.07. What is the ratio of the Aid flow from UN agencies (US$) of Cote d'Ivoire in 2010 to that in 2013?
Provide a short and direct response. 0.15. What is the ratio of the Aid flow from UN agencies (US$) in Lower middle income in 2011 to that in 2012?
Give a very brief answer. 1.01. What is the ratio of the Aid flow from UN agencies (US$) in Other small states in 2011 to that in 2012?
Give a very brief answer. 1.29. What is the ratio of the Aid flow from UN agencies (US$) in Burundi in 2011 to that in 2012?
Provide a succinct answer. 0.23. What is the ratio of the Aid flow from UN agencies (US$) of Cote d'Ivoire in 2011 to that in 2012?
Your answer should be compact. 0.01. What is the ratio of the Aid flow from UN agencies (US$) of Lower middle income in 2011 to that in 2013?
Your answer should be very brief. 1.84. What is the ratio of the Aid flow from UN agencies (US$) in Other small states in 2011 to that in 2013?
Offer a terse response. 8.63. What is the ratio of the Aid flow from UN agencies (US$) of Burundi in 2011 to that in 2013?
Ensure brevity in your answer.  0.12. What is the ratio of the Aid flow from UN agencies (US$) of Cote d'Ivoire in 2011 to that in 2013?
Provide a succinct answer. 0.01. What is the ratio of the Aid flow from UN agencies (US$) in Lower middle income in 2012 to that in 2013?
Your response must be concise. 1.82. What is the ratio of the Aid flow from UN agencies (US$) in Other small states in 2012 to that in 2013?
Offer a very short reply. 6.7. What is the ratio of the Aid flow from UN agencies (US$) of Burundi in 2012 to that in 2013?
Give a very brief answer. 0.54. What is the ratio of the Aid flow from UN agencies (US$) of Cote d'Ivoire in 2012 to that in 2013?
Your answer should be compact. 0.74. What is the difference between the highest and the second highest Aid flow from UN agencies (US$) of Other small states?
Offer a very short reply. 3.00e+04. What is the difference between the highest and the second highest Aid flow from UN agencies (US$) of Burundi?
Your response must be concise. 4.29e+06. What is the difference between the highest and the lowest Aid flow from UN agencies (US$) in Lower middle income?
Keep it short and to the point. 1.13e+07. What is the difference between the highest and the lowest Aid flow from UN agencies (US$) of Other small states?
Give a very brief answer. 4.38e+06. What is the difference between the highest and the lowest Aid flow from UN agencies (US$) of Burundi?
Provide a succinct answer. 1.31e+07. What is the difference between the highest and the lowest Aid flow from UN agencies (US$) of Cote d'Ivoire?
Offer a very short reply. 4.43e+06. 